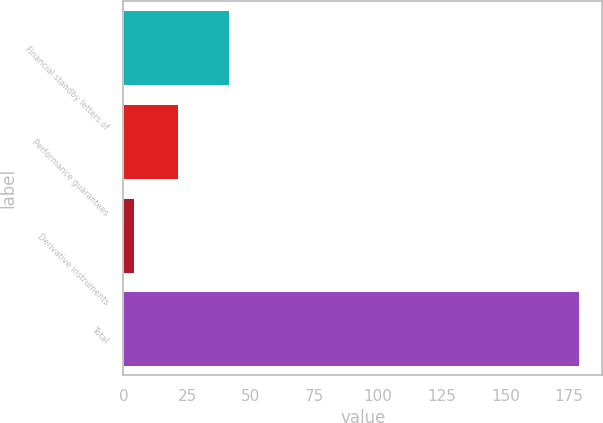Convert chart. <chart><loc_0><loc_0><loc_500><loc_500><bar_chart><fcel>Financial standby letters of<fcel>Performance guarantees<fcel>Derivative instruments<fcel>Total<nl><fcel>41.4<fcel>21.6<fcel>4.1<fcel>179.1<nl></chart> 